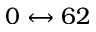<formula> <loc_0><loc_0><loc_500><loc_500>0 \leftrightarrow 6 2</formula> 